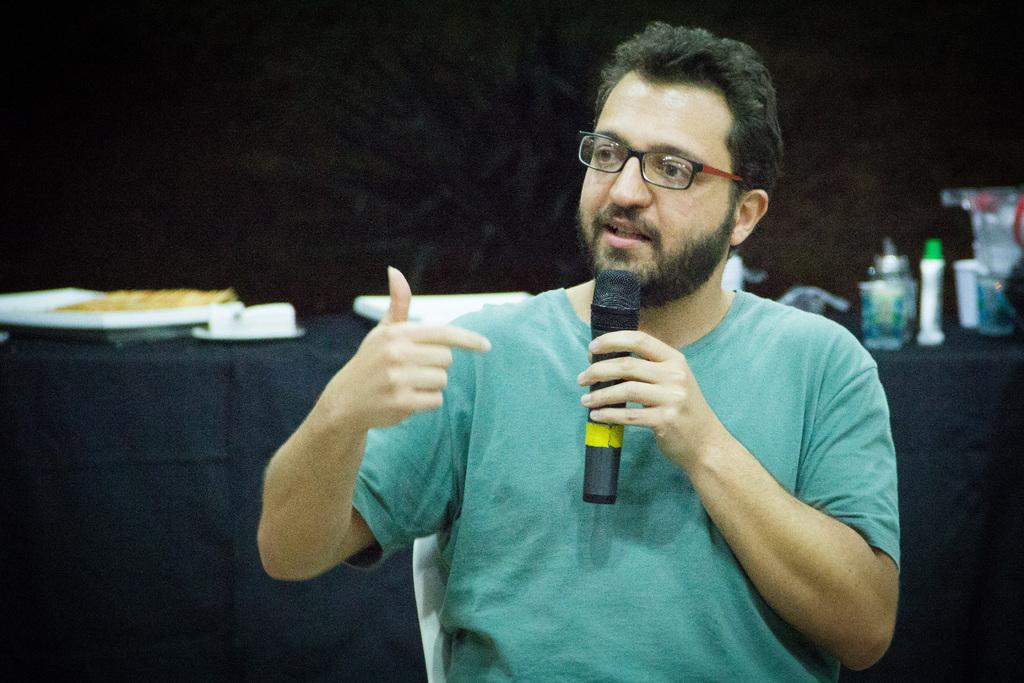What is the man in the image doing? The man is sitting on a chair and holding a mic. What can be seen on the man's face? The man is wearing glasses. What is visible in the background of the image? There are trays, food, a bottle, and other objects on the table in the background of the image. What is the value of the poison in the image? There is no poison present in the image, so it is not possible to determine its value. 